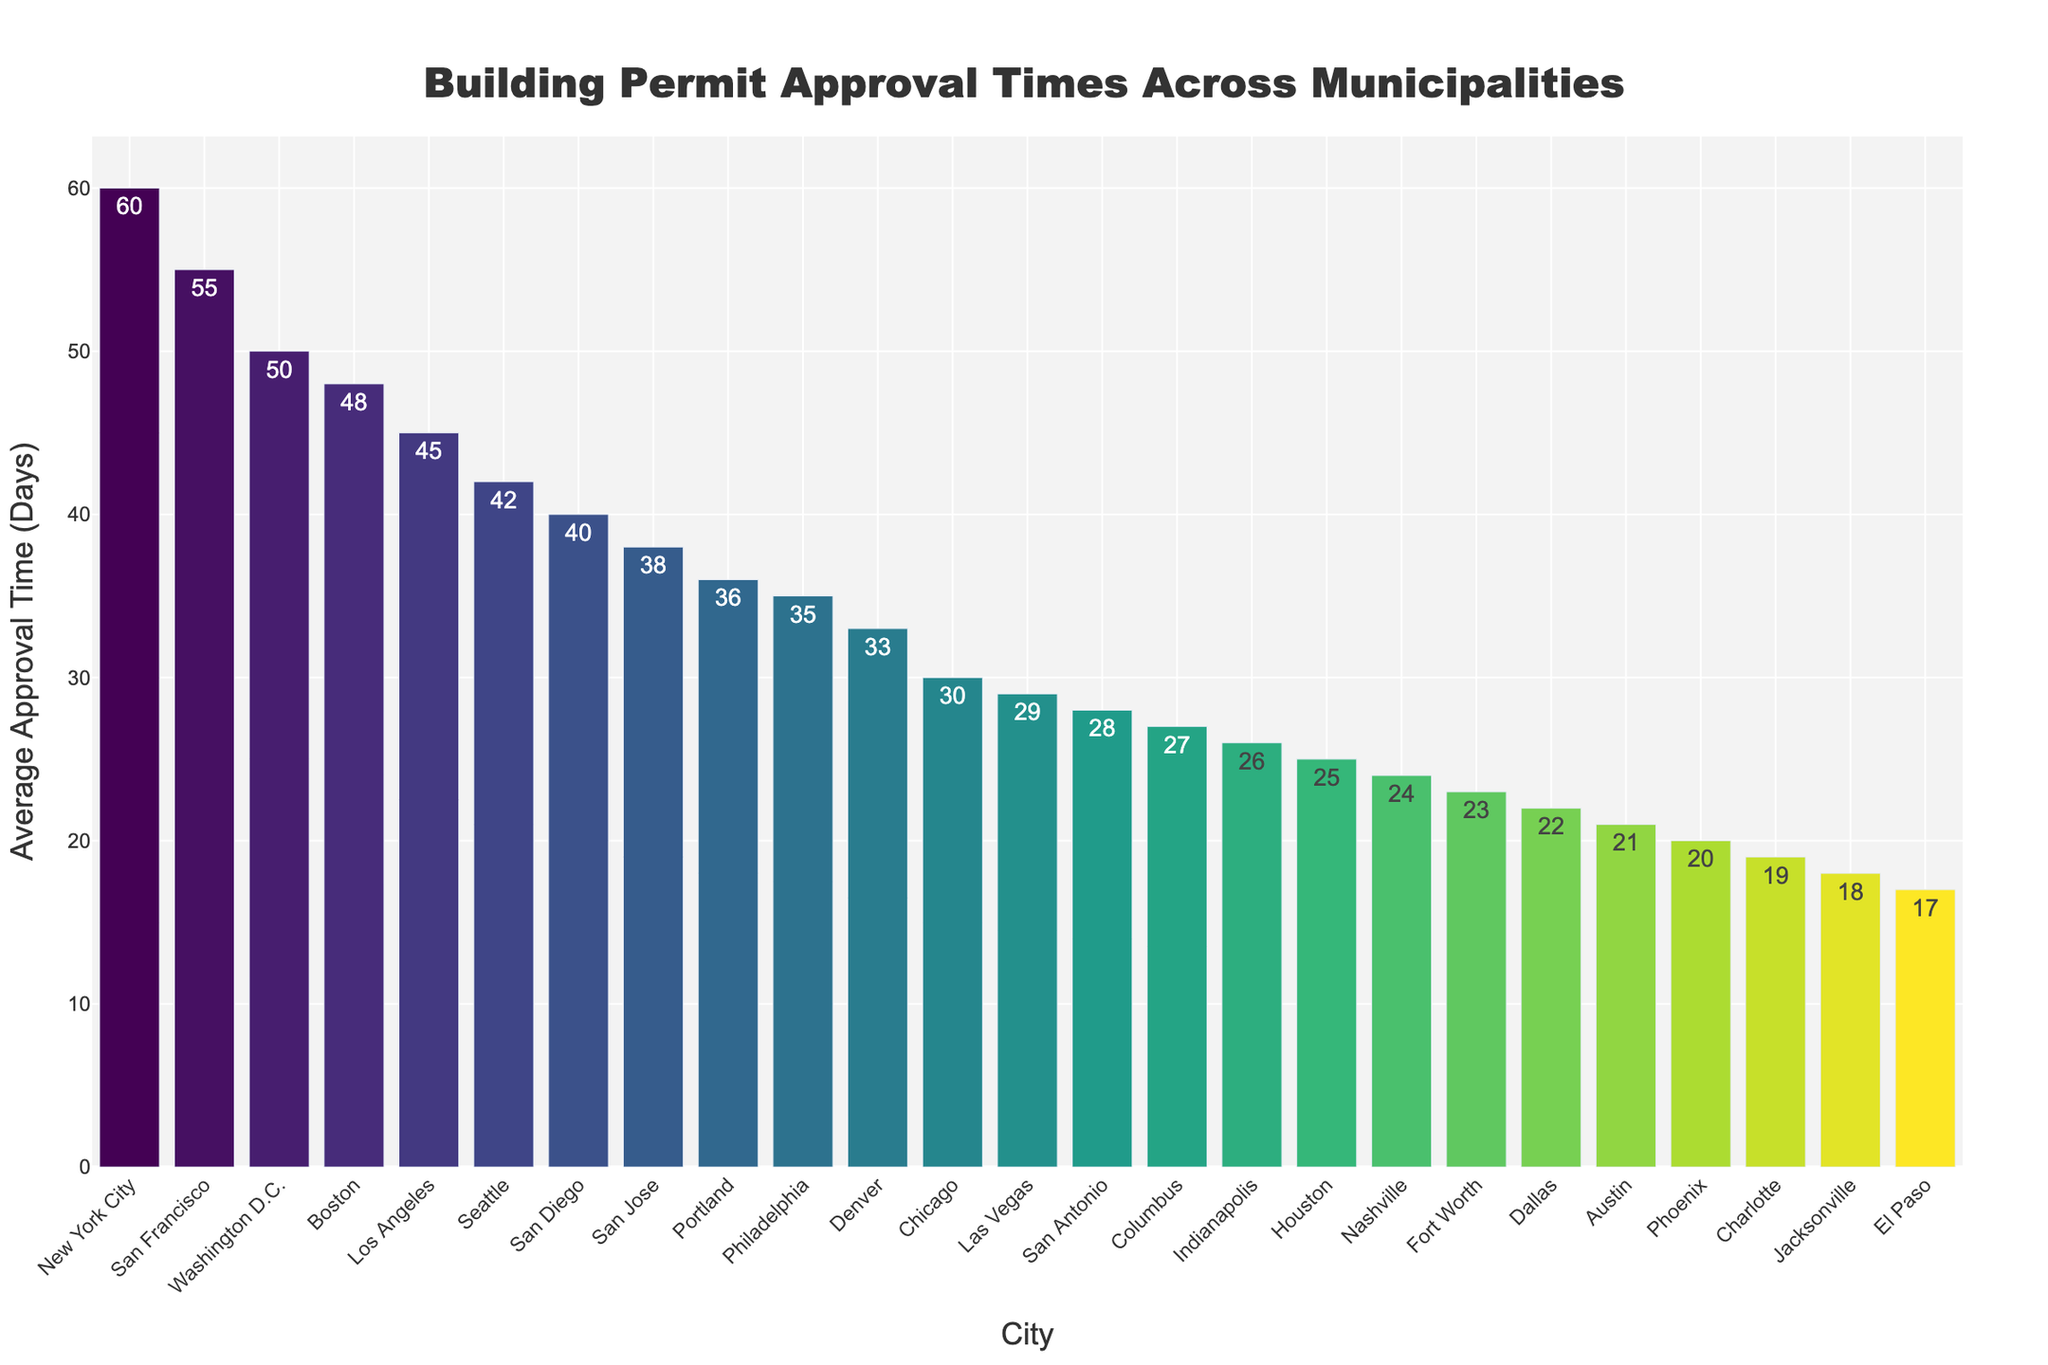Which city has the shortest permit approval time? The figure shows that El Paso has the shortest average permit approval time, represented by the shortest bar.
Answer: El Paso Which city has the longest permit approval time? The figure shows that New York City has the longest average permit approval time, represented by the tallest bar.
Answer: New York City How many cities have an average permit approval time longer than 30 days? By examining the bars in the figure, we can count the cities with bars longer than the 30-day mark. These cities are New York City, Los Angeles, Philadelphia, San Francisco, Seattle, Boston, Washington D.C., and Portland.
Answer: 8 Which city has a shorter permit approval time: Austin or Dallas? By comparing the bars for Austin and Dallas, Austin has a shorter average permit approval time than Dallas.
Answer: Austin What is the difference in permit approval times between Washington D.C. and Boston? The permit approval time for Washington D.C. is 50 days, and for Boston, it is 48 days. The difference is 50 - 48 = 2 days.
Answer: 2 days What is the average permit approval time for the top 5 cities with the longest approval times? The top 5 cities with the longest approval times are New York City (60 days), San Francisco (55 days), Washington D.C. (50 days), Boston (48 days), and Seattle (42 days). The average is calculated as (60 + 55 + 50 + 48 + 42) / 5 = 51 days.
Answer: 51 days Which city has an average permit approval time closest to 25 days? By looking at the figure, we find that Houston has an approval time of 25 days, which is exactly 25 days.
Answer: Houston Are there more cities with average permit approval times less than or equal to 30 days or more than 30 days? By counting the cities, we see that there are 10 cities with average approval times less than or equal to 30 days and 14 cities with averages more than 30 days.
Answer: More than 30 days What's the total of the average permit approval times for Los Angeles and Phoenix? Los Angeles has an average approval time of 45 days, and Phoenix has 20 days. The total is 45 + 20 = 65 days.
Answer: 65 days 